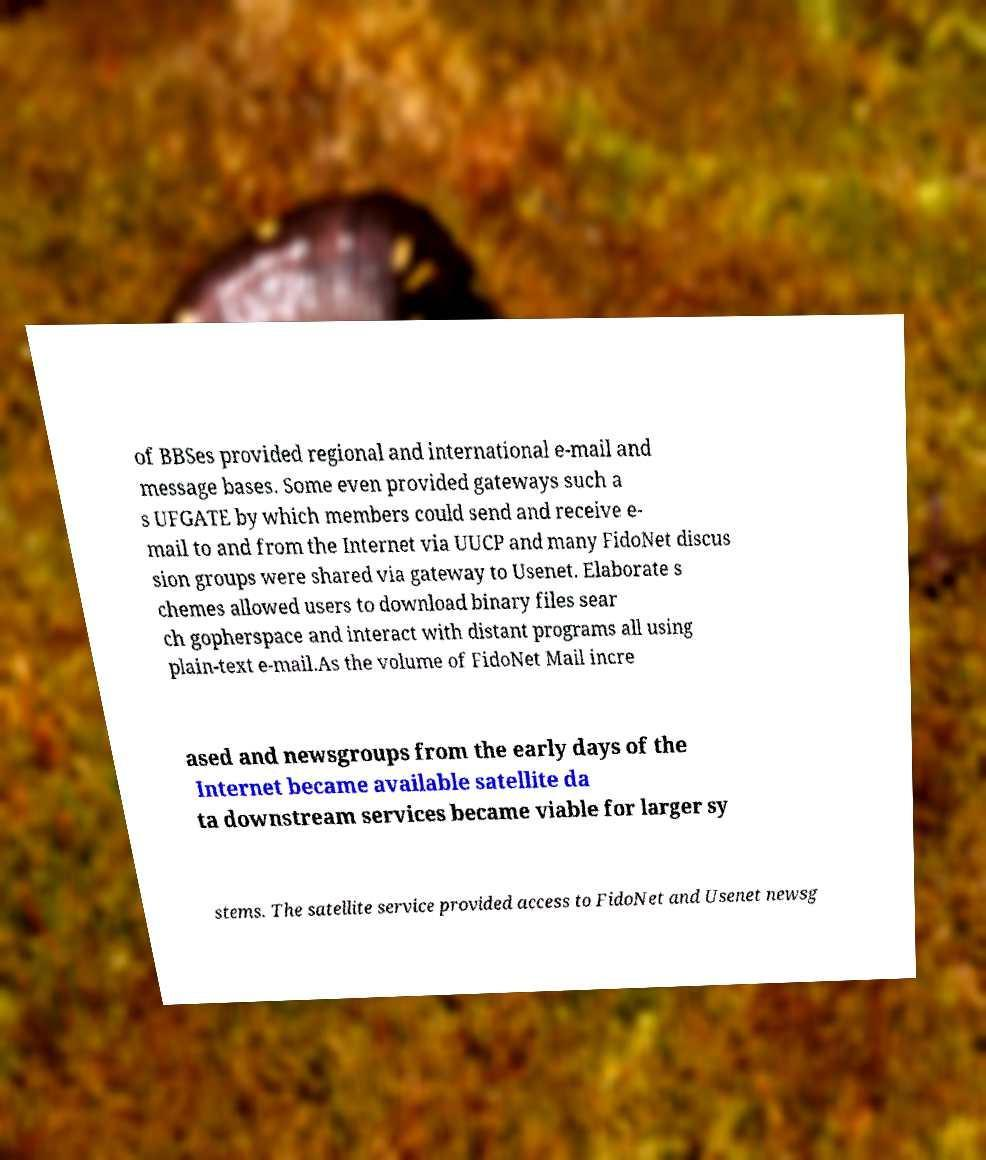I need the written content from this picture converted into text. Can you do that? of BBSes provided regional and international e-mail and message bases. Some even provided gateways such a s UFGATE by which members could send and receive e- mail to and from the Internet via UUCP and many FidoNet discus sion groups were shared via gateway to Usenet. Elaborate s chemes allowed users to download binary files sear ch gopherspace and interact with distant programs all using plain-text e-mail.As the volume of FidoNet Mail incre ased and newsgroups from the early days of the Internet became available satellite da ta downstream services became viable for larger sy stems. The satellite service provided access to FidoNet and Usenet newsg 